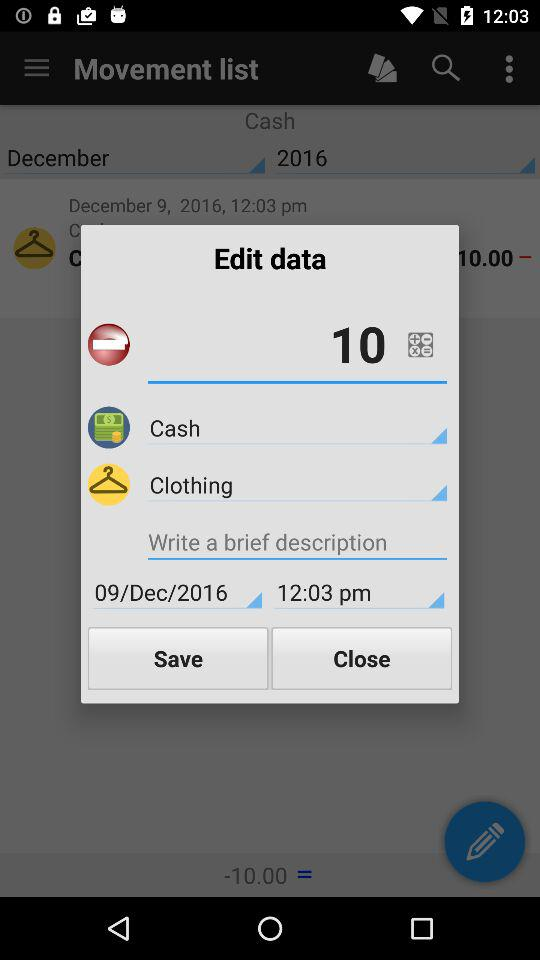What is the time? The time is 12:03 pm. 